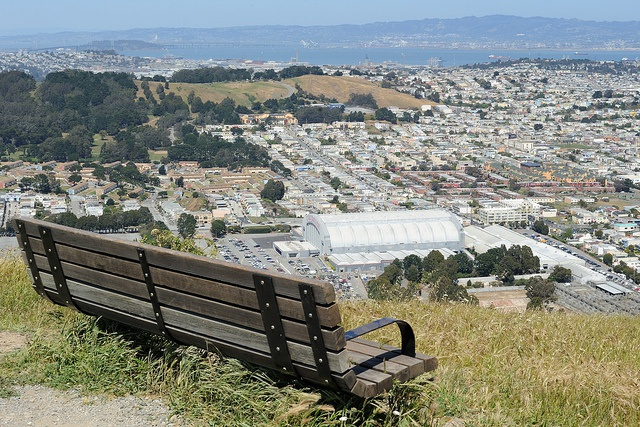Describe the objects in this image and their specific colors. I can see bench in lightblue, black, gray, and darkgray tones, car in lightblue, darkgray, lightgray, black, and gray tones, car in lightblue, lightgray, gray, and black tones, car in lightblue, darkgray, lightgray, and gray tones, and car in lightblue, darkgray, lightgray, brown, and gray tones in this image. 